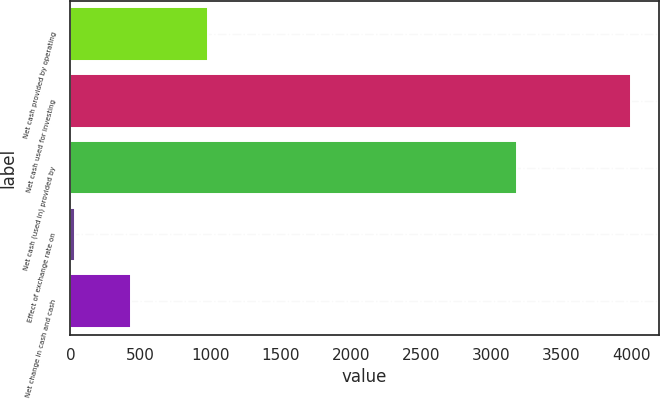Convert chart to OTSL. <chart><loc_0><loc_0><loc_500><loc_500><bar_chart><fcel>Net cash provided by operating<fcel>Net cash used for investing<fcel>Net cash (used in) provided by<fcel>Effect of exchange rate on<fcel>Net change in cash and cash<nl><fcel>982.4<fcel>3994.9<fcel>3184.6<fcel>35.7<fcel>431.62<nl></chart> 